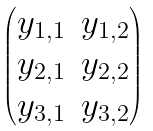Convert formula to latex. <formula><loc_0><loc_0><loc_500><loc_500>\begin{pmatrix} y _ { 1 , 1 } & y _ { 1 , 2 } \\ y _ { 2 , 1 } & y _ { 2 , 2 } \\ y _ { 3 , 1 } & y _ { 3 , 2 } \end{pmatrix}</formula> 